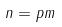Convert formula to latex. <formula><loc_0><loc_0><loc_500><loc_500>n = p m</formula> 